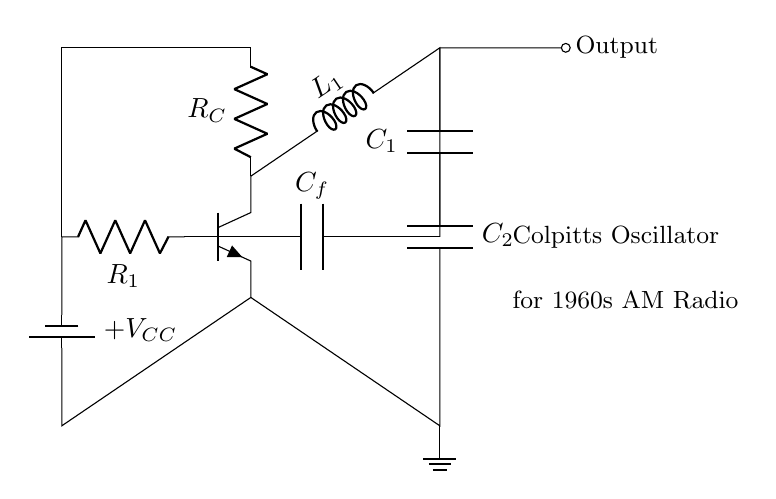What type of oscillator is shown in the circuit? The circuit is identified as a Colpitts oscillator, as indicated by the labeling in the diagram and its characteristic tank circuit with capacitors and an inductor.
Answer: Colpitts What is the role of capacitors C1 and C2 in the circuit? Capacitors C1 and C2 form part of the tank circuit in the Colpitts oscillator, creating a resonant circuit that determines the frequency of oscillation.
Answer: Resonance What is the purpose of the inductor L1 in the circuit? The inductor L1 works in conjunction with the capacitors to form an oscillatory circuit, enabling the generation of alternating current at a specific frequency.
Answer: Oscillation How is the transistor biased in this circuit? The transistor is biased through resistor R1 connected to the voltage supply, allowing proper operation in the active region for amplification and oscillation.
Answer: Resistor R1 What is the feedback component in the circuit? The feedback in the Colpitts oscillator is provided by the capacitor C_f, which connects from the collector to the base of the transistor, facilitating the required feedback for oscillation.
Answer: Capacitor C_f What effect do the values of C1 and C2 have on the frequency? The values of C1 and C2 affect the resonant frequency of the oscillator: lower capacitance results in a higher frequency, while higher capacitance reduces the frequency.
Answer: Resonant frequency 